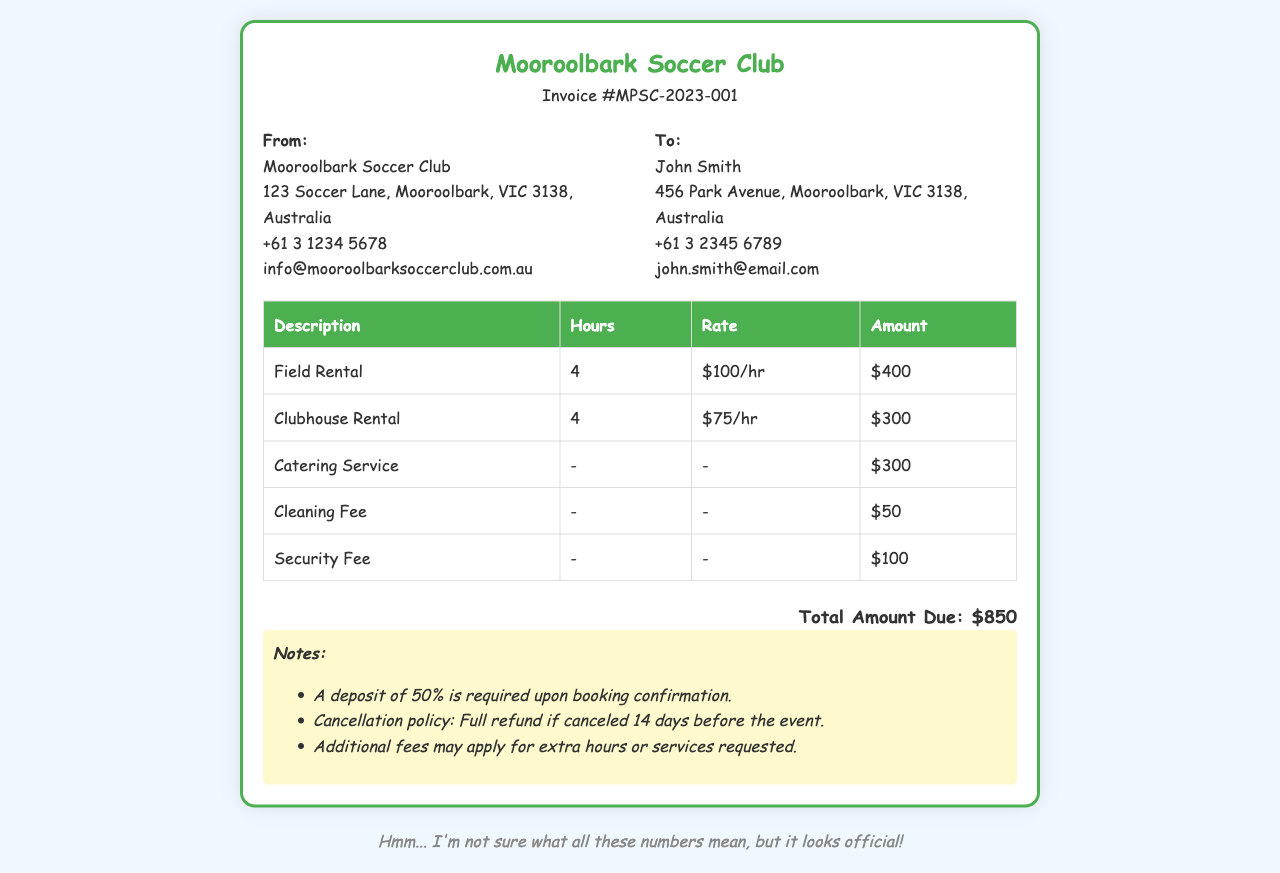What is the invoice number? The invoice number is listed at the top of the document under the title.
Answer: MPSC-2023-001 Who is the invoice addressed to? The "To" section of the document specifies the recipient's name.
Answer: John Smith What is the total amount due? The total amount due is located near the bottom of the invoice.
Answer: $850 How many hours was the Field Rental for? The "Hours" column next to "Field Rental" provides the duration.
Answer: 4 What is the rate per hour for the Clubhouse Rental? The rate is shown in the "Rate" column next to "Clubhouse Rental".
Answer: $75/hr What is the amount charged for the Catering Service? The catering service amount can be found in the respective row in the table.
Answer: $300 Is there a cleaning fee mentioned in the invoice? The invoice lists a cleaning fee in one of the rows.
Answer: Yes What is the cancellation policy? The notes section outlines the cancellation policy details.
Answer: Full refund if canceled 14 days before the event What percentage of the total is required as a deposit? The notes section mentions the deposit percentage required.
Answer: 50% 